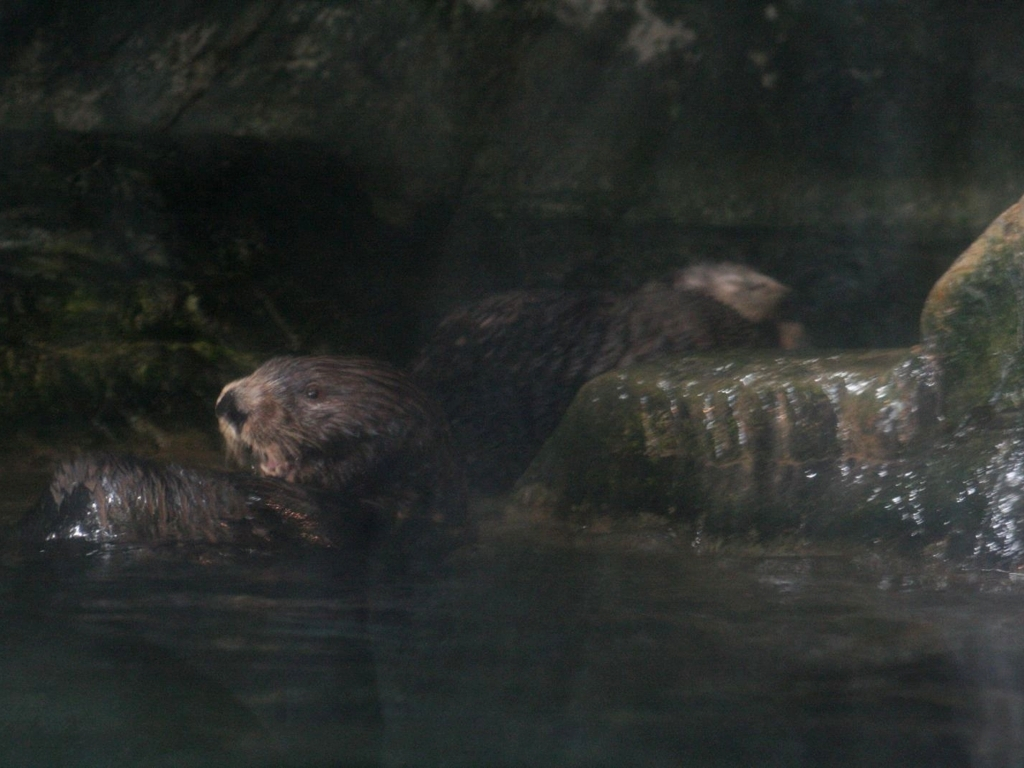What kind of animals are depicted in this image? The image features two otters. They are semiaquatic mammals known for their playfulness and agility in the water. 